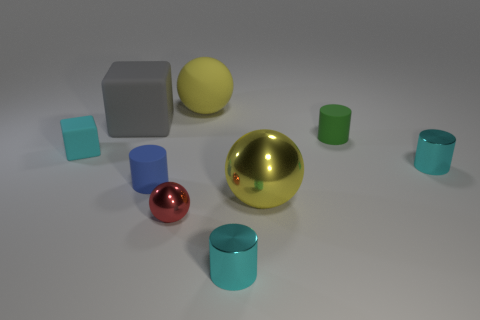The rubber object that is the same size as the gray matte cube is what shape?
Ensure brevity in your answer.  Sphere. What number of other objects are the same color as the matte ball?
Give a very brief answer. 1. What number of other things are there of the same material as the green thing
Your answer should be very brief. 4. Do the red thing and the matte object in front of the small cyan cube have the same size?
Provide a succinct answer. Yes. What color is the tiny block?
Provide a succinct answer. Cyan. There is a yellow object that is in front of the small object behind the cyan thing on the left side of the small blue rubber cylinder; what shape is it?
Provide a succinct answer. Sphere. The big yellow thing that is in front of the large gray rubber object that is behind the blue matte cylinder is made of what material?
Offer a terse response. Metal. What shape is the other big object that is the same material as the red thing?
Your answer should be very brief. Sphere. Is there any other thing that has the same shape as the blue matte thing?
Make the answer very short. Yes. There is a tiny green thing; how many yellow metallic things are behind it?
Offer a terse response. 0. 